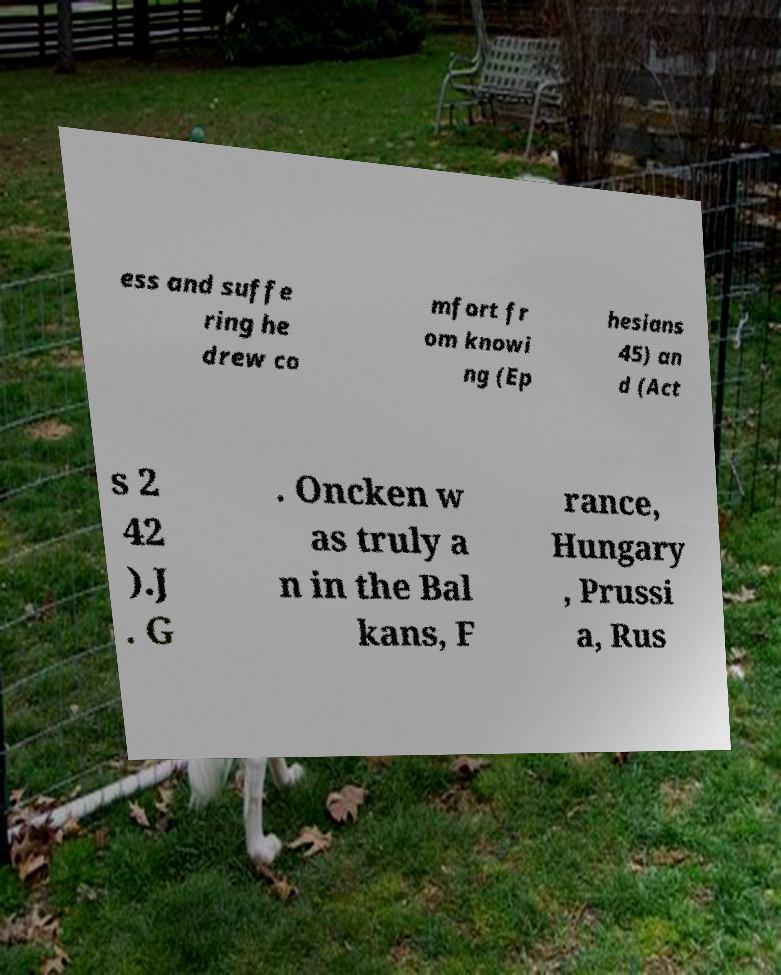Please identify and transcribe the text found in this image. ess and suffe ring he drew co mfort fr om knowi ng (Ep hesians 45) an d (Act s 2 42 ).J . G . Oncken w as truly a n in the Bal kans, F rance, Hungary , Prussi a, Rus 